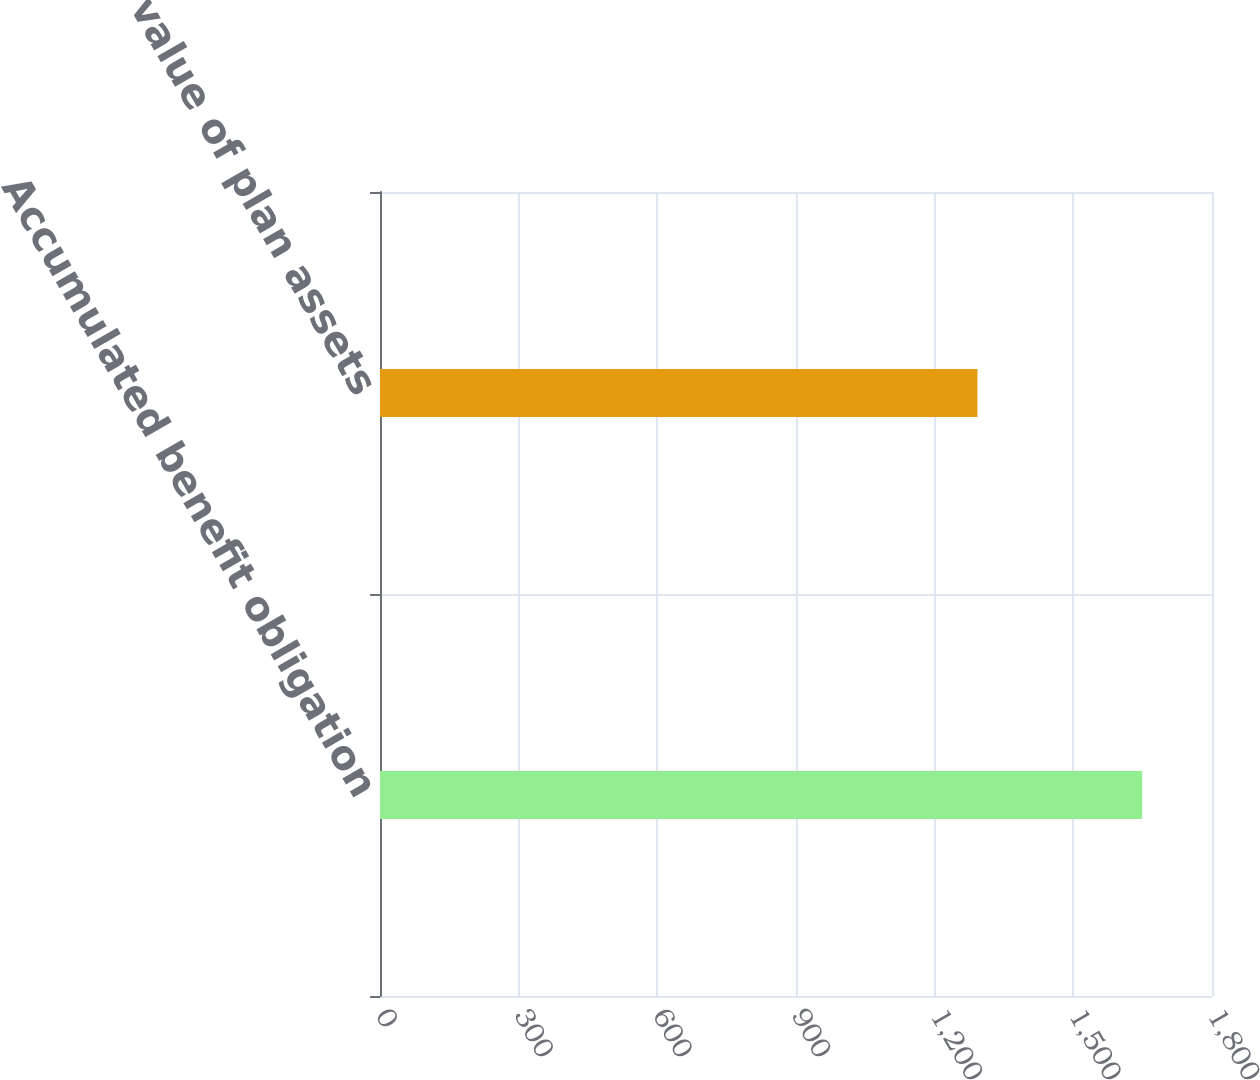Convert chart. <chart><loc_0><loc_0><loc_500><loc_500><bar_chart><fcel>Accumulated benefit obligation<fcel>Fair value of plan assets<nl><fcel>1648.9<fcel>1292.6<nl></chart> 